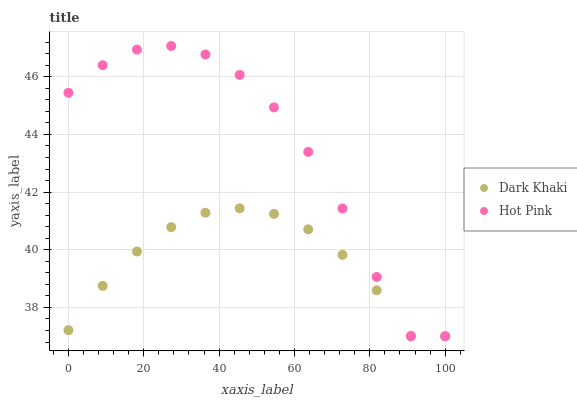Does Dark Khaki have the minimum area under the curve?
Answer yes or no. Yes. Does Hot Pink have the maximum area under the curve?
Answer yes or no. Yes. Does Hot Pink have the minimum area under the curve?
Answer yes or no. No. Is Dark Khaki the smoothest?
Answer yes or no. Yes. Is Hot Pink the roughest?
Answer yes or no. Yes. Is Hot Pink the smoothest?
Answer yes or no. No. Does Dark Khaki have the lowest value?
Answer yes or no. Yes. Does Hot Pink have the highest value?
Answer yes or no. Yes. Does Dark Khaki intersect Hot Pink?
Answer yes or no. Yes. Is Dark Khaki less than Hot Pink?
Answer yes or no. No. Is Dark Khaki greater than Hot Pink?
Answer yes or no. No. 